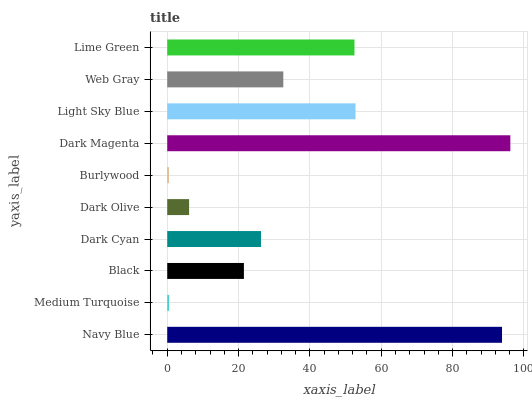Is Burlywood the minimum?
Answer yes or no. Yes. Is Dark Magenta the maximum?
Answer yes or no. Yes. Is Medium Turquoise the minimum?
Answer yes or no. No. Is Medium Turquoise the maximum?
Answer yes or no. No. Is Navy Blue greater than Medium Turquoise?
Answer yes or no. Yes. Is Medium Turquoise less than Navy Blue?
Answer yes or no. Yes. Is Medium Turquoise greater than Navy Blue?
Answer yes or no. No. Is Navy Blue less than Medium Turquoise?
Answer yes or no. No. Is Web Gray the high median?
Answer yes or no. Yes. Is Dark Cyan the low median?
Answer yes or no. Yes. Is Black the high median?
Answer yes or no. No. Is Burlywood the low median?
Answer yes or no. No. 